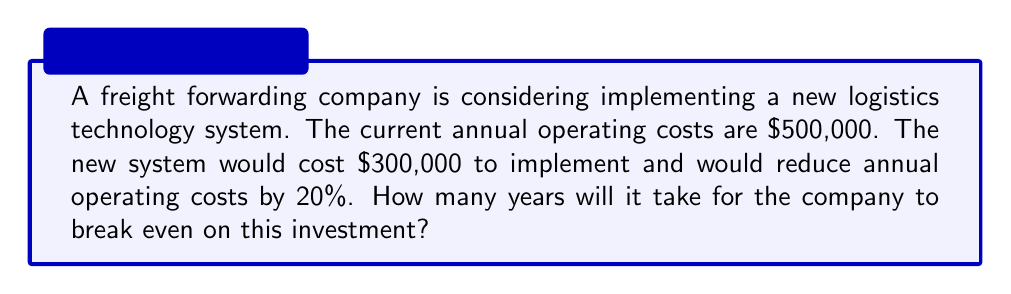Show me your answer to this math problem. Let's approach this step-by-step:

1. Calculate the new annual operating costs:
   Current costs = $500,000
   Reduction = 20% = 0.2
   New annual costs = $500,000 * (1 - 0.2) = $400,000

2. Calculate the annual savings:
   Annual savings = Current costs - New costs
   $$ \text{Annual savings} = 500,000 - 400,000 = 100,000 $$

3. Set up the break-even equation:
   Let $x$ be the number of years to break even.
   At the break-even point, the total savings equal the implementation cost:
   $$ 300,000 = 100,000x $$

4. Solve for $x$:
   $$ x = \frac{300,000}{100,000} = 3 $$

Therefore, it will take 3 years for the company to break even on this investment.
Answer: 3 years 